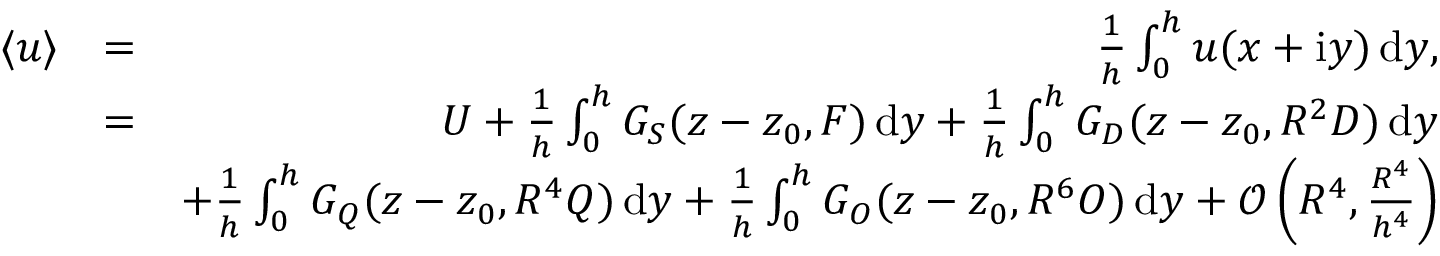<formula> <loc_0><loc_0><loc_500><loc_500>\begin{array} { r l r } { \langle u \rangle } & { = } & { \frac { 1 } { h } \int _ { 0 } ^ { h } u ( x + i y ) \, d y , } \\ & { = } & { U + \frac { 1 } { h } \int _ { 0 } ^ { h } G _ { S } ( z - z _ { 0 } , F ) \, d y + \frac { 1 } { h } \int _ { 0 } ^ { h } G _ { D } ( z - z _ { 0 } , R ^ { 2 } D ) \, d y } \\ & { + \frac { 1 } { h } \int _ { 0 } ^ { h } G _ { Q } ( z - z _ { 0 } , R ^ { 4 } Q ) \, d y + \frac { 1 } { h } \int _ { 0 } ^ { h } G _ { O } ( z - z _ { 0 } , R ^ { 6 } O ) \, d y + \mathcal { O } \left ( R ^ { 4 } , \frac { R ^ { 4 } } { h ^ { 4 } } \right ) } \end{array}</formula> 